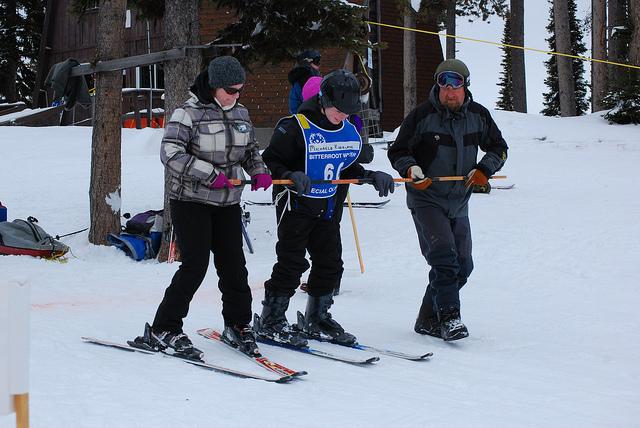What color is the middle persons shirt?
Be succinct. Black. Which person is the teacher?
Answer briefly. Man on right. Are all three people wearing hats?
Give a very brief answer. Yes. 